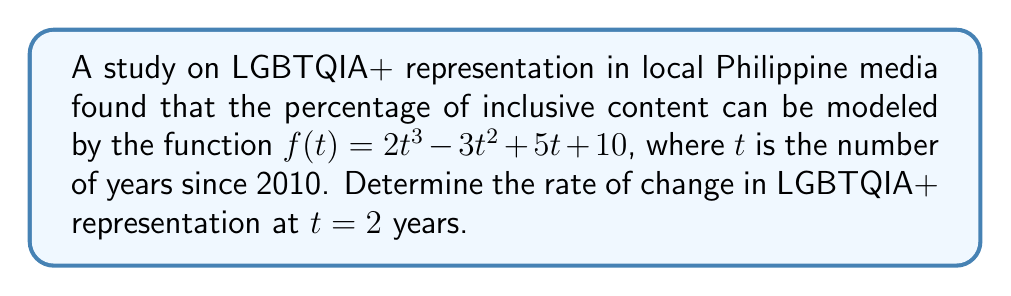Provide a solution to this math problem. To find the rate of change at a specific point, we need to calculate the derivative of the function and evaluate it at the given point.

Step 1: Find the derivative of $f(t)$
$$f(t) = 2t^3 - 3t^2 + 5t + 10$$
$$f'(t) = 6t^2 - 6t + 5$$

Step 2: Evaluate the derivative at $t = 2$
$$f'(2) = 6(2)^2 - 6(2) + 5$$
$$f'(2) = 6(4) - 12 + 5$$
$$f'(2) = 24 - 12 + 5$$
$$f'(2) = 17$$

The rate of change at $t = 2$ years is 17 percentage points per year.
Answer: 17 percentage points/year 